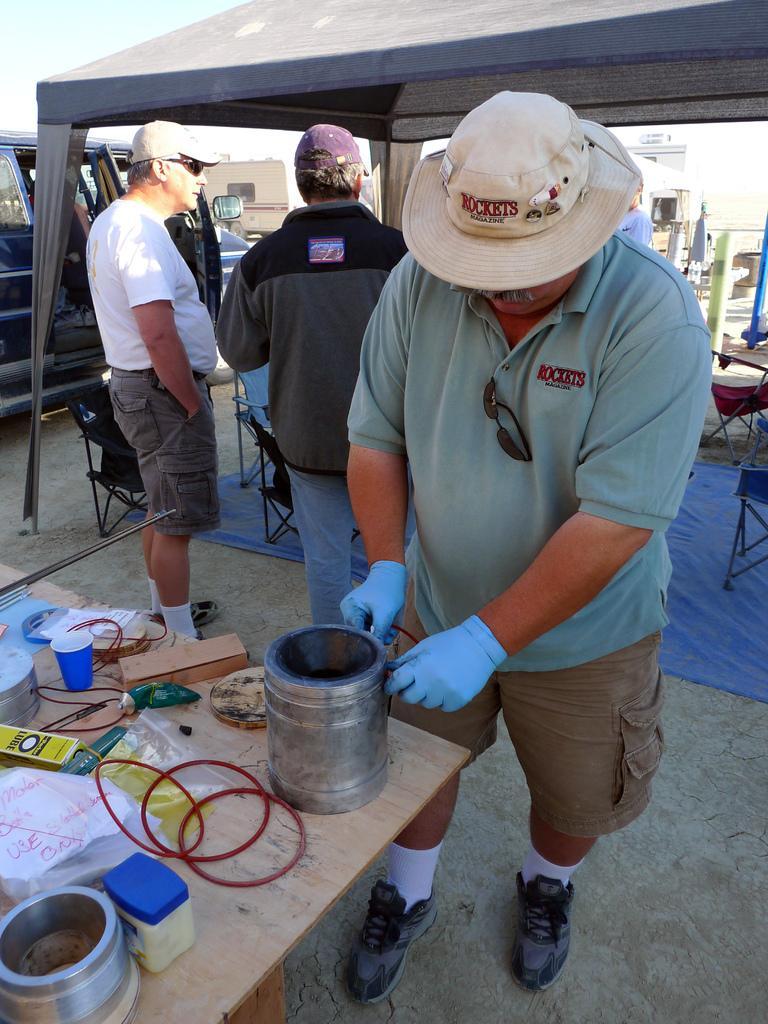Please provide a concise description of this image. In this picture, we can see three people standing on the path and in front of the man there is a table and on the table there is a cup, polythene covers and other items. Behind the people there is a stall, chairs and a vehicle parked on the path and behind the vehicle there is a sky. 